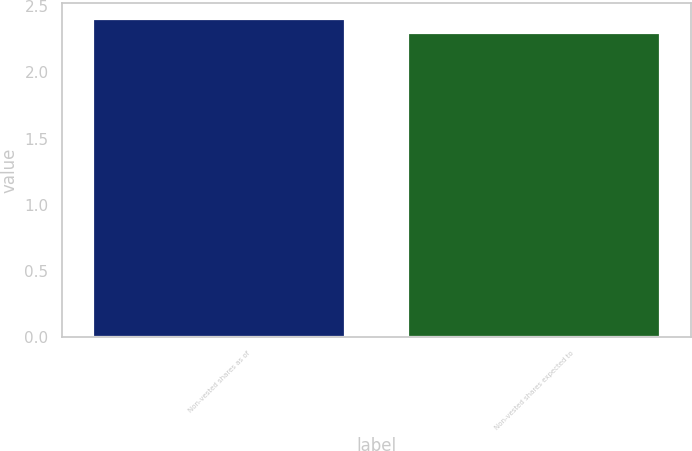Convert chart. <chart><loc_0><loc_0><loc_500><loc_500><bar_chart><fcel>Non-vested shares as of<fcel>Non-vested shares expected to<nl><fcel>2.4<fcel>2.3<nl></chart> 